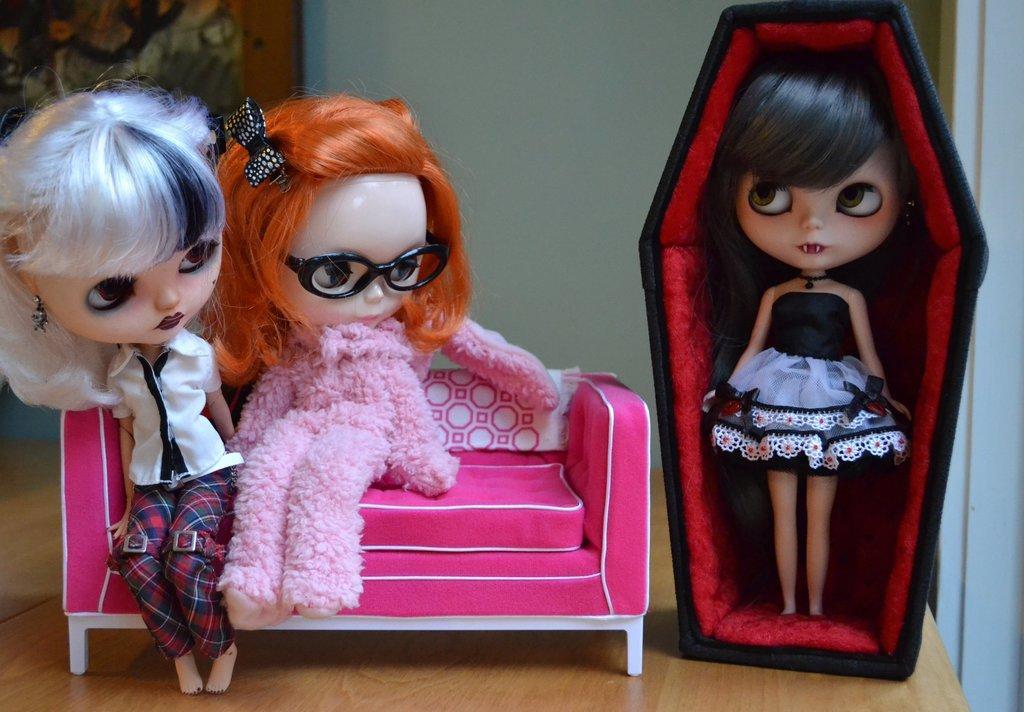Please provide a concise description of this image. In this image there are three toys, where a toy is standing, another two toys are sitting on the couch, on the wooden board, and in the background there is a wall. 